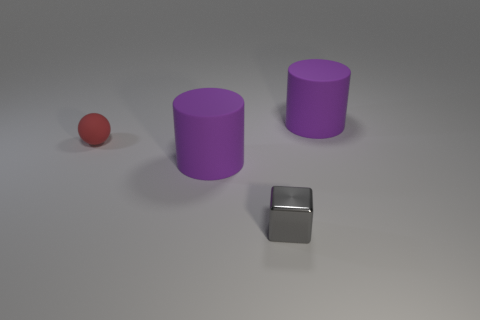What number of matte cylinders have the same size as the ball?
Keep it short and to the point. 0. Are the tiny thing left of the metal cube and the thing behind the small red object made of the same material?
Your answer should be very brief. Yes. Is there anything else that is the same shape as the tiny matte object?
Your answer should be very brief. No. The cube is what color?
Your answer should be compact. Gray. What is the color of the metal thing that is the same size as the ball?
Your answer should be compact. Gray. Is there a gray metal block?
Offer a very short reply. Yes. What shape is the tiny gray object that is right of the small matte sphere?
Provide a succinct answer. Cube. What number of objects are both on the left side of the tiny gray shiny block and in front of the matte sphere?
Make the answer very short. 1. Are there any gray cubes made of the same material as the tiny red ball?
Offer a very short reply. No. What number of cylinders are either large purple matte objects or tiny shiny things?
Provide a succinct answer. 2. 